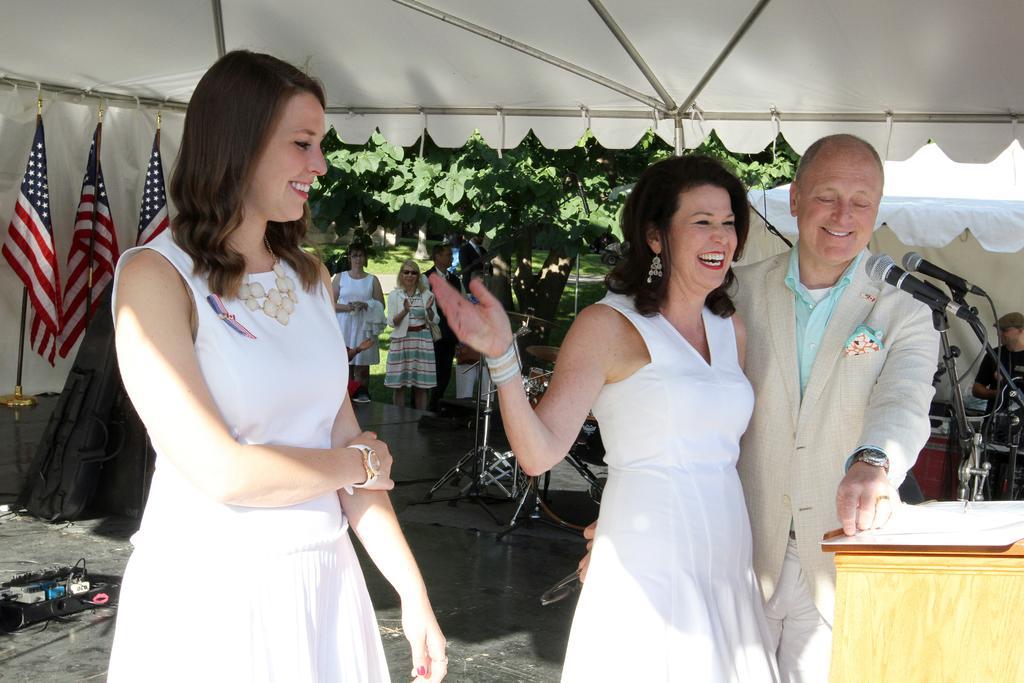Please provide a concise description of this image. In this picture I can see there are three people standing and smiling and among them there are two women wearing white dresses and there is a table here with micro phones and there are flags in the backdrop and there are few people standing at the tree. 